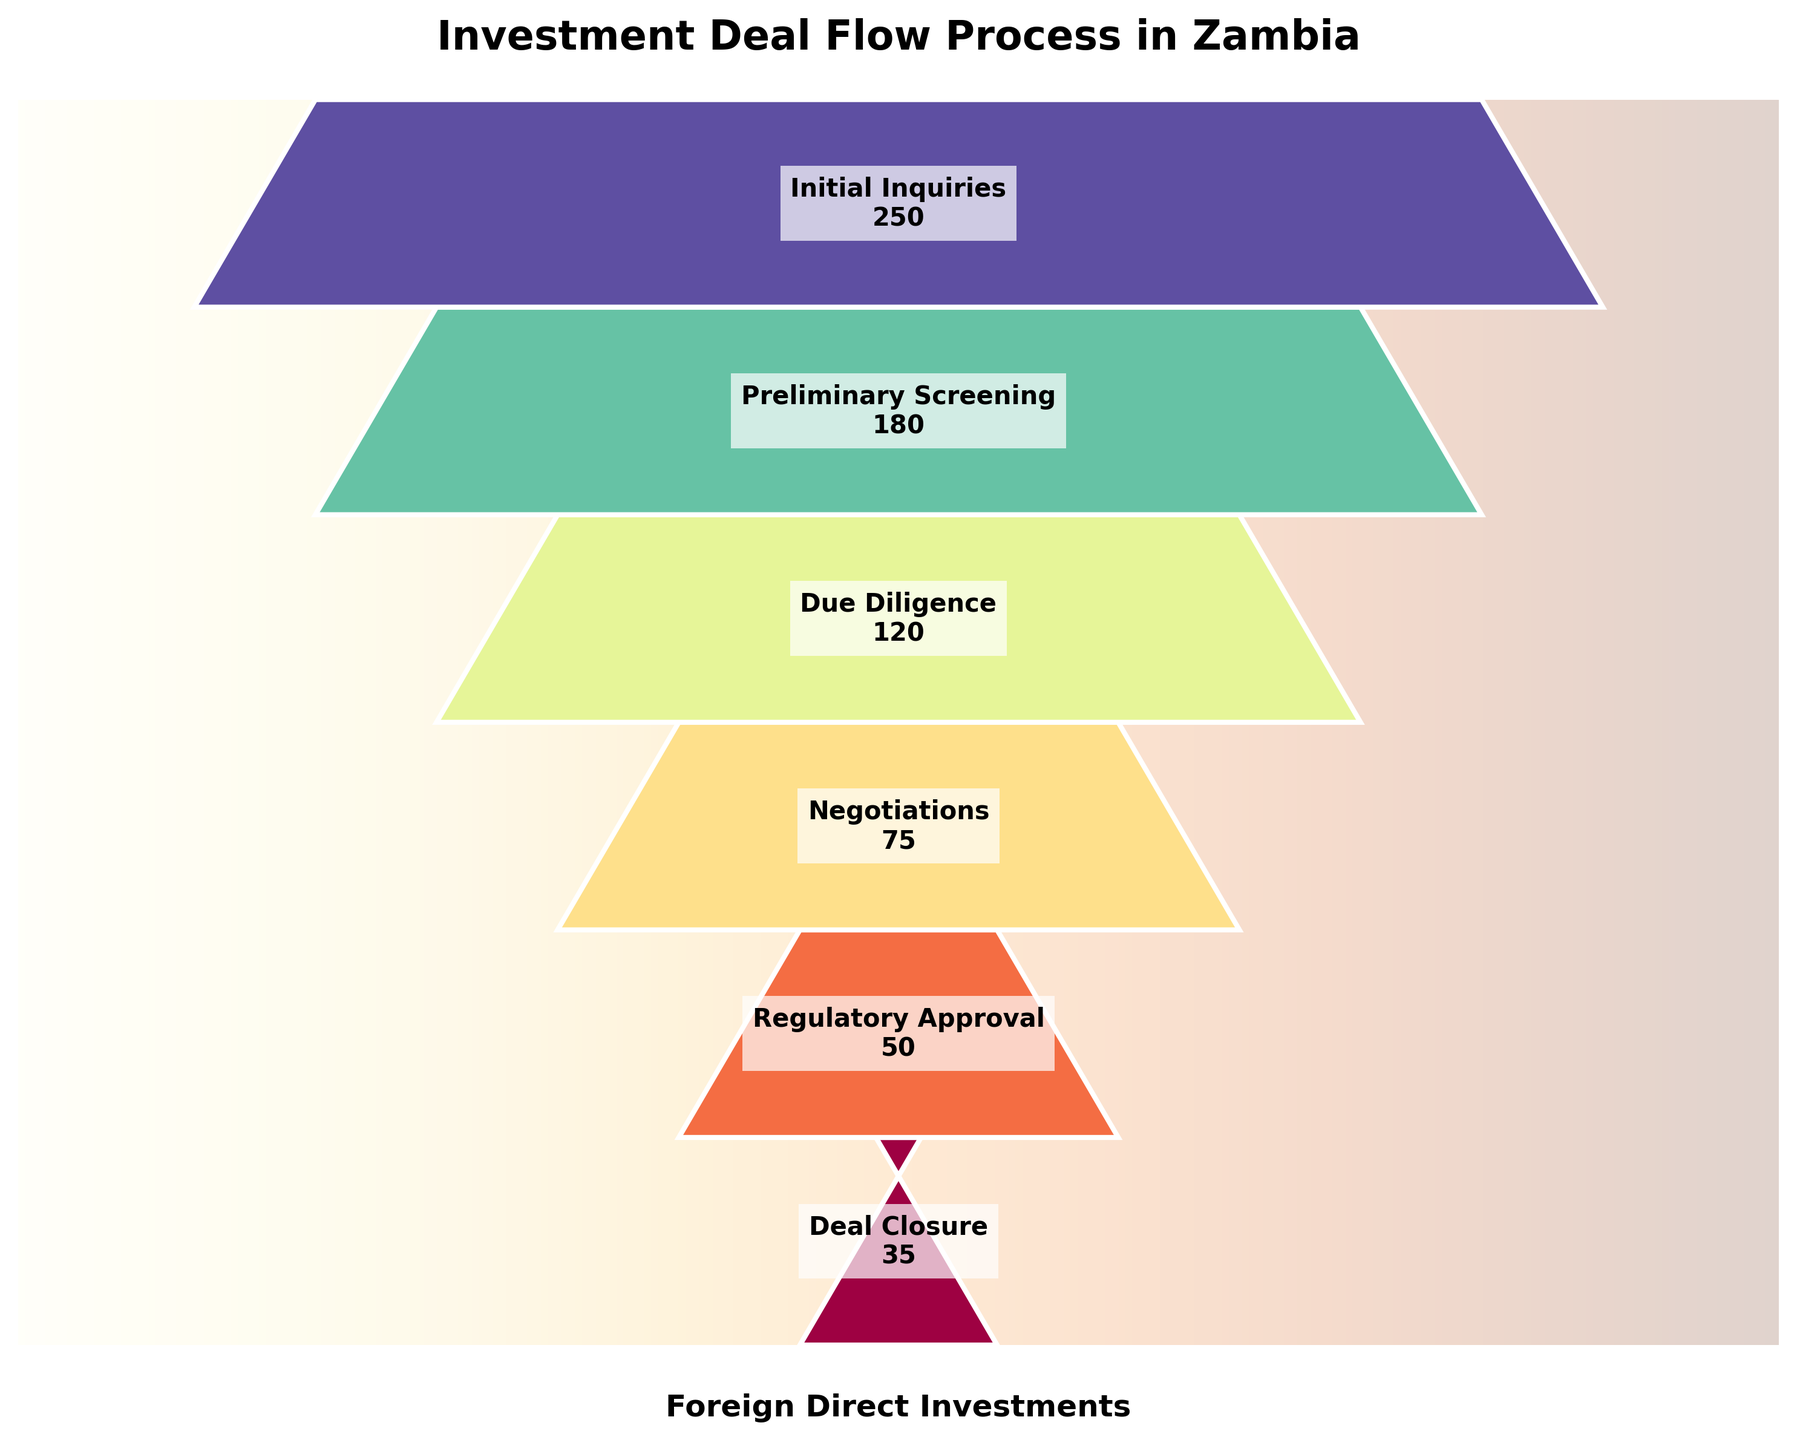What is the title of the plot? The title of the plot is generally positioned at the top of the figure in larger, bold font to quickly inform viewers about the subject of the chart. By looking at the top of the figure, one can identify the title as "Investment Deal Flow Process in Zambia".
Answer: Investment Deal Flow Process in Zambia How many stages are depicted in the funnel chart? The funnel chart categorizes the investment deal flow process into distinct stages. By counting the individual stages labeled with the respective number of deals, we observe that there are six stages.
Answer: Six Which stage has the highest number of deals, and how many deals are there? The highest number of deals typically appears at the top of the funnel. Observing the funnel chart, the "Initial Inquiries" stage has the highest number of deals, totaling 250.
Answer: Initial Inquiries, 250 What is the decrease in the number of deals from the "Initial Inquiries" stage to the "Deal Closure" stage? To find the decrease, subtract the number of deals in the "Deal Closure" stage from the "Initial Inquiries" stage. So, 250 (Initial Inquiries) - 35 (Deal Closure) = 215.
Answer: 215 By how much does the number of deals decrease between the "Preliminary Screening" and "Negotiations" stages? Subtract the number of deals in the "Negotiations" stage from the number in the "Preliminary Screening" stage. Thus, 180 (Preliminary Screening) - 75 (Negotiations) = 105.
Answer: 105 Which stage experiences the largest drop in the number of deals compared to the previous stage? Reviewing each stage, the largest drop can be found by comparing the differences. The drop between "Due Diligence" (120 deals) and "Negotiations" (75 deals) is the largest, amounting to 45 deals.
Answer: Due Diligence to Negotiations What percentage of the initial inquiries successfully reach the due diligence stage? To calculate the percentage, divide the number of deals in the due diligence stage by the number of initial inquiries and multiply by 100. Therefore, (120 / 250) * 100 = 48%.
Answer: 48% What is the average number of deals across all stages? Compute the average by summing the number of deals in all stages and dividing by the number of stages. (250 + 180 + 120 + 75 + 50 + 35) / 6 = 710 / 6 ≈ 118.33.
Answer: 118.33 Which two consecutive stages have the smallest decrease in the number of deals? Identify the pair of consecutive stages with the smallest difference in deals. Comparing each drop: "Negotiations" to "Regulatory Approval" has the smallest drop, with 25 deals (75 - 50).
Answer: Negotiations to Regulatory Approval 